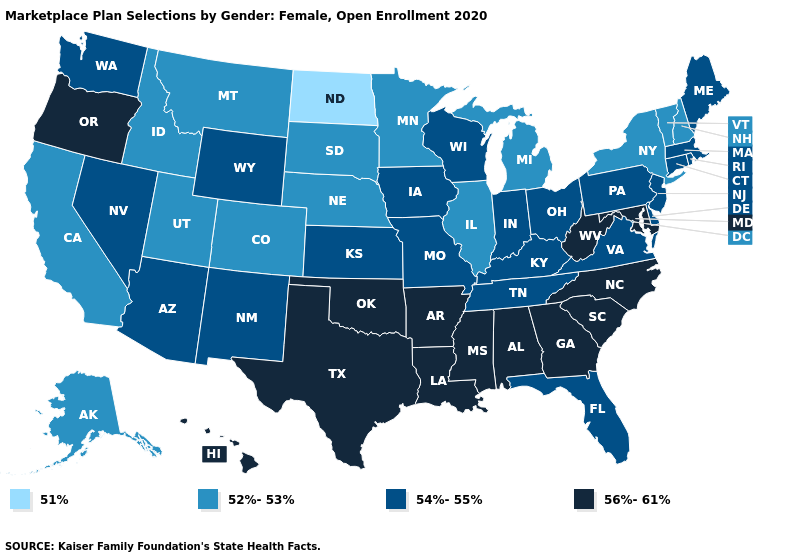Name the states that have a value in the range 52%-53%?
Be succinct. Alaska, California, Colorado, Idaho, Illinois, Michigan, Minnesota, Montana, Nebraska, New Hampshire, New York, South Dakota, Utah, Vermont. Among the states that border Michigan , which have the lowest value?
Give a very brief answer. Indiana, Ohio, Wisconsin. What is the highest value in the USA?
Quick response, please. 56%-61%. Does the map have missing data?
Write a very short answer. No. What is the value of Utah?
Quick response, please. 52%-53%. Does Michigan have the lowest value in the USA?
Give a very brief answer. No. Name the states that have a value in the range 52%-53%?
Be succinct. Alaska, California, Colorado, Idaho, Illinois, Michigan, Minnesota, Montana, Nebraska, New Hampshire, New York, South Dakota, Utah, Vermont. Name the states that have a value in the range 54%-55%?
Keep it brief. Arizona, Connecticut, Delaware, Florida, Indiana, Iowa, Kansas, Kentucky, Maine, Massachusetts, Missouri, Nevada, New Jersey, New Mexico, Ohio, Pennsylvania, Rhode Island, Tennessee, Virginia, Washington, Wisconsin, Wyoming. Among the states that border Minnesota , which have the highest value?
Write a very short answer. Iowa, Wisconsin. What is the value of New Hampshire?
Be succinct. 52%-53%. Does New Hampshire have the highest value in the Northeast?
Quick response, please. No. What is the lowest value in the USA?
Answer briefly. 51%. Which states have the lowest value in the USA?
Quick response, please. North Dakota. What is the highest value in the West ?
Write a very short answer. 56%-61%. Name the states that have a value in the range 56%-61%?
Keep it brief. Alabama, Arkansas, Georgia, Hawaii, Louisiana, Maryland, Mississippi, North Carolina, Oklahoma, Oregon, South Carolina, Texas, West Virginia. 